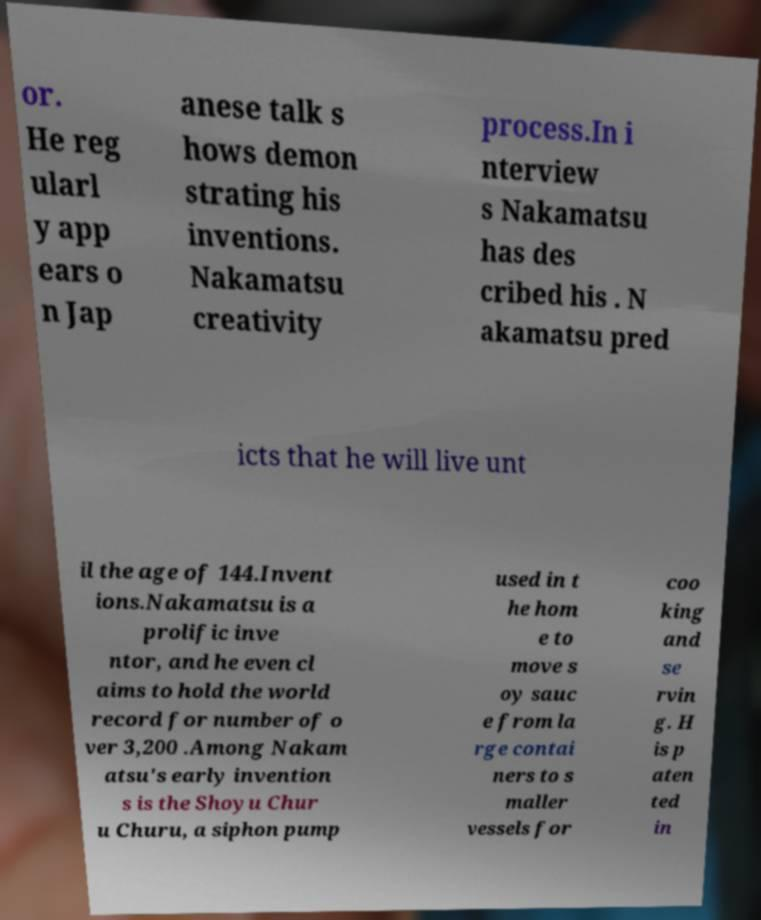Can you read and provide the text displayed in the image?This photo seems to have some interesting text. Can you extract and type it out for me? or. He reg ularl y app ears o n Jap anese talk s hows demon strating his inventions. Nakamatsu creativity process.In i nterview s Nakamatsu has des cribed his . N akamatsu pred icts that he will live unt il the age of 144.Invent ions.Nakamatsu is a prolific inve ntor, and he even cl aims to hold the world record for number of o ver 3,200 .Among Nakam atsu's early invention s is the Shoyu Chur u Churu, a siphon pump used in t he hom e to move s oy sauc e from la rge contai ners to s maller vessels for coo king and se rvin g. H is p aten ted in 